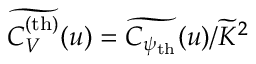Convert formula to latex. <formula><loc_0><loc_0><loc_500><loc_500>\widetilde { C _ { V } ^ { ( t h ) } } ( u ) = \widetilde { C _ { \psi _ { t h } } } ( u ) / \widetilde { K } ^ { 2 }</formula> 